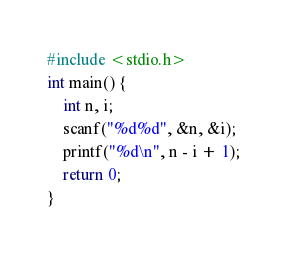<code> <loc_0><loc_0><loc_500><loc_500><_C_>#include <stdio.h>
int main() {
	int n, i;
	scanf("%d%d", &n, &i);
	printf("%d\n", n - i + 1);
	return 0;
}</code> 